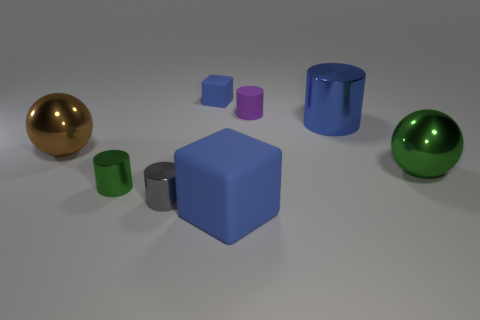Which objects have a reflective surface? The surfaces of all the objects appear to have a reflective quality. However, the gold and green balls and the blue cylinder exhibit a higher degree of reflectiveness, with clear reflections and highlights visible. 